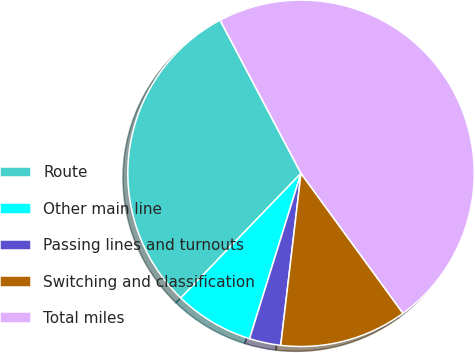Convert chart to OTSL. <chart><loc_0><loc_0><loc_500><loc_500><pie_chart><fcel>Route<fcel>Other main line<fcel>Passing lines and turnouts<fcel>Switching and classification<fcel>Total miles<nl><fcel>30.05%<fcel>7.41%<fcel>2.93%<fcel>11.89%<fcel>47.72%<nl></chart> 